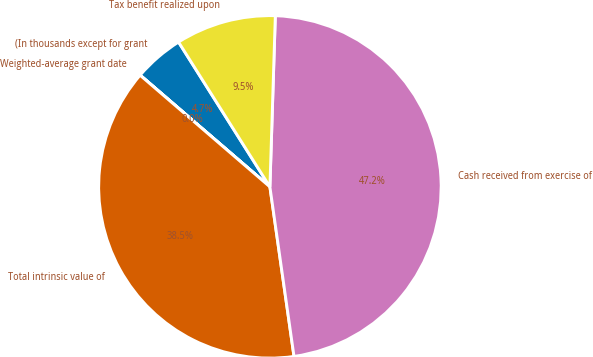Convert chart to OTSL. <chart><loc_0><loc_0><loc_500><loc_500><pie_chart><fcel>(In thousands except for grant<fcel>Weighted-average grant date<fcel>Total intrinsic value of<fcel>Cash received from exercise of<fcel>Tax benefit realized upon<nl><fcel>4.73%<fcel>0.01%<fcel>38.55%<fcel>47.25%<fcel>9.46%<nl></chart> 